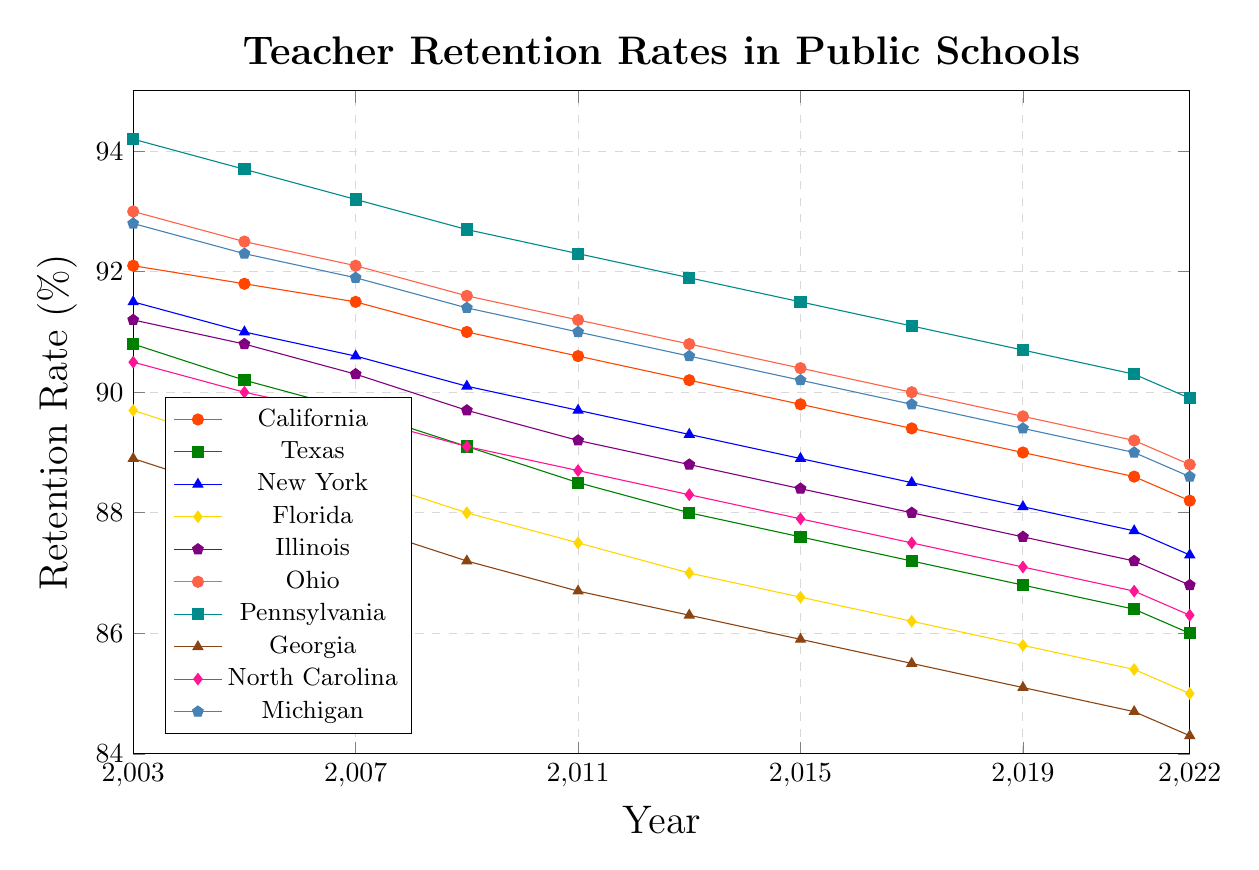Which state had the highest retention rate in 2003? Look at the data points in the year 2003 for all the states. Pennsylvania, Ohio, California, and Michigan show high retention rates, but Pennsylvania has the highest rate at 94.2%.
Answer: Pennsylvania Which state experienced the largest decrease in retention rate from 2003 to 2022? Calculate the differences in retention rates between 2003 and 2022 for all states. Georgia had an initial rate of 88.9% in 2003 and ended with 84.3% in 2022, which is a decrease of 4.6%, the largest among all states.
Answer: Georgia Which state has consistently had the highest retention rate across the years? Evaluate the retention rates year by year for each state. Pennsylvania consistently appears with the highest retention rates from 2003 to 2022.
Answer: Pennsylvania How did the retention rate in New York change from 2003 to 2022? Subtract the retention rate of New York in 2022 from that of 2003: 91.5% - 87.3% = 4.2%.
Answer: Decreased by 4.2% Was there any year where Texas had a higher retention rate than California? Compare the retention rates of Texas and California year by year. Throughout the years, California's retention rate was always higher than Texas's retention rate.
Answer: No Which state had the steepest decline in retention rate between 2009 and 2011? Calculate the difference between the retention rates in 2009 and 2011 for each state. Georgia had a retention rate of 87.2% in 2009 and 86.7% in 2011, a decline of 0.5%, larger than any other state’s decline during this period.
Answer: Georgia What's the average retention rate for Ohio over the whole period? Sum all the retention rates for Ohio across the years and divide by the number of years: (93.0 + 92.5 + 92.1 + 91.6 + 91.2 + 90.8 + 90.4 + 90.0 + 89.6 + 89.2 + 88.8) / 11 = 90.7%.
Answer: 90.7% What is the least retention rate recorded for any state over the entire dataset? Look for the smallest retention rate in the figure. Georgia had the lowest retention rate with 84.3% in 2022.
Answer: 84.3% In which year did Florida have the retention rate that fell below 87% for the first time? Examine Florida's data points year by year until you find the first instance of the rate dropping below 87%. Florida's retention rate fell below 87% for the first time in 2013 with a rate of 87.0%.
Answer: 2013 